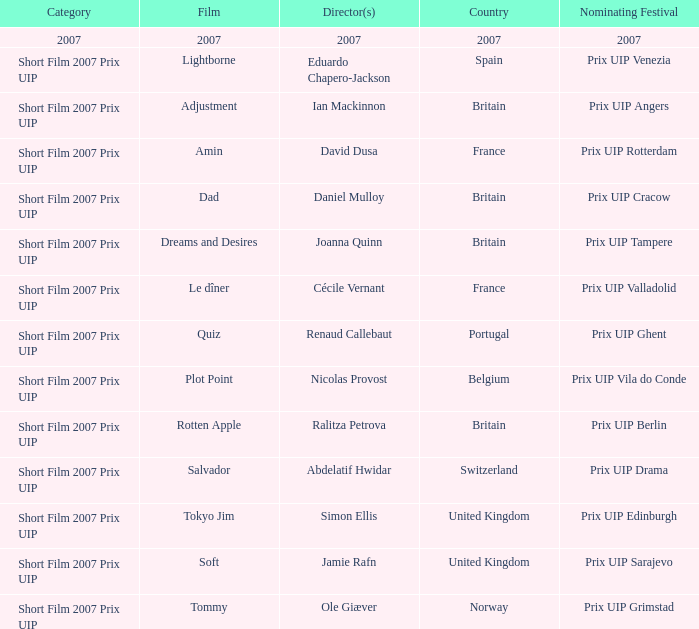What Country has a Director of 2007? 2007.0. 